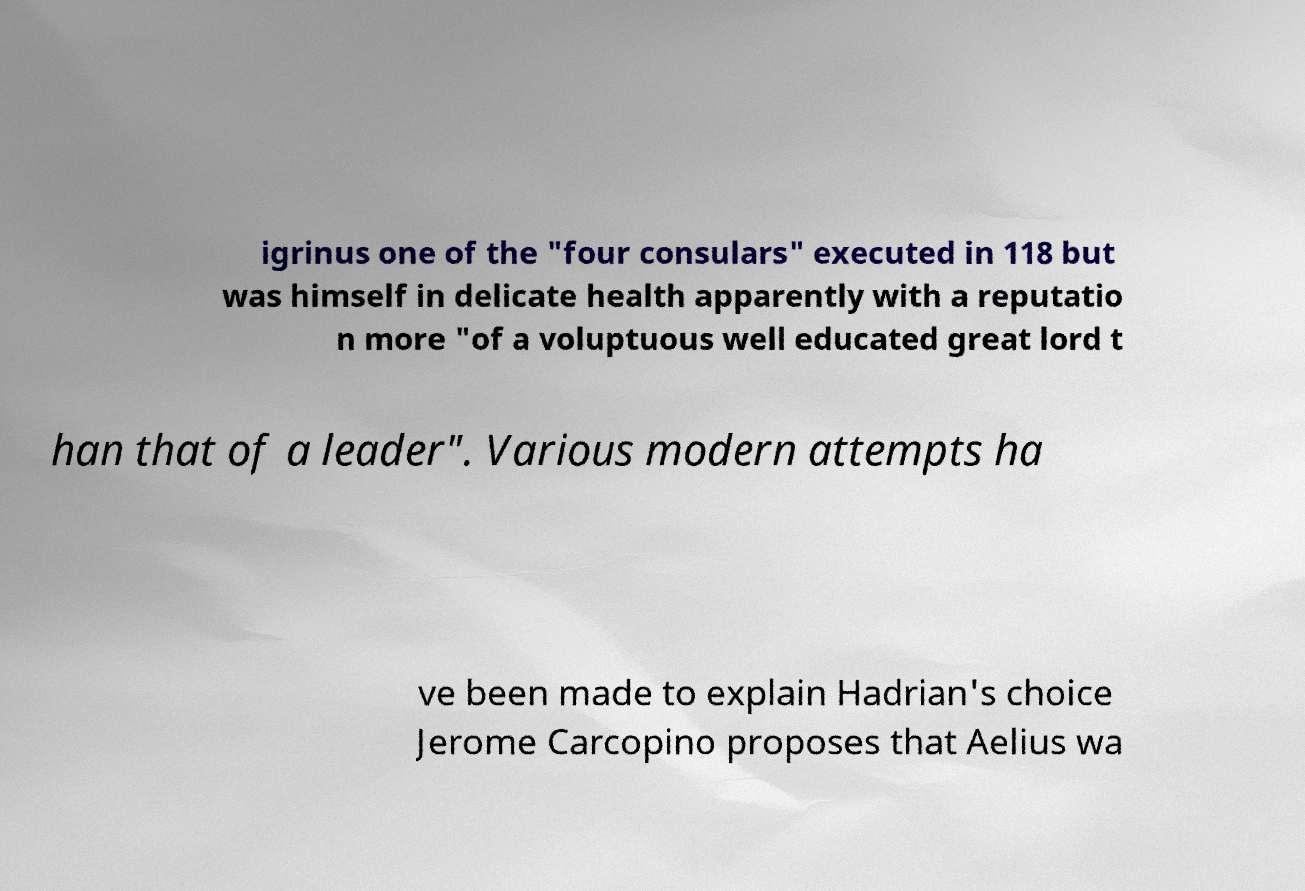Can you read and provide the text displayed in the image?This photo seems to have some interesting text. Can you extract and type it out for me? igrinus one of the "four consulars" executed in 118 but was himself in delicate health apparently with a reputatio n more "of a voluptuous well educated great lord t han that of a leader". Various modern attempts ha ve been made to explain Hadrian's choice Jerome Carcopino proposes that Aelius wa 